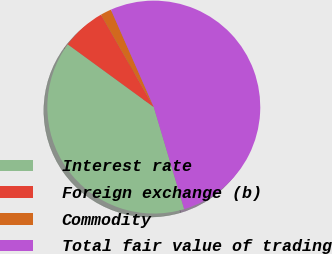Convert chart. <chart><loc_0><loc_0><loc_500><loc_500><pie_chart><fcel>Interest rate<fcel>Foreign exchange (b)<fcel>Commodity<fcel>Total fair value of trading<nl><fcel>39.64%<fcel>6.7%<fcel>1.67%<fcel>51.99%<nl></chart> 